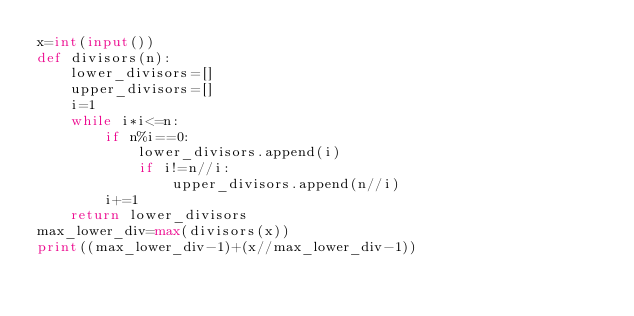<code> <loc_0><loc_0><loc_500><loc_500><_Python_>x=int(input())
def divisors(n):
    lower_divisors=[]
    upper_divisors=[]
    i=1
    while i*i<=n:
        if n%i==0:
            lower_divisors.append(i)
            if i!=n//i:
                upper_divisors.append(n//i)
        i+=1
    return lower_divisors
max_lower_div=max(divisors(x))
print((max_lower_div-1)+(x//max_lower_div-1))</code> 